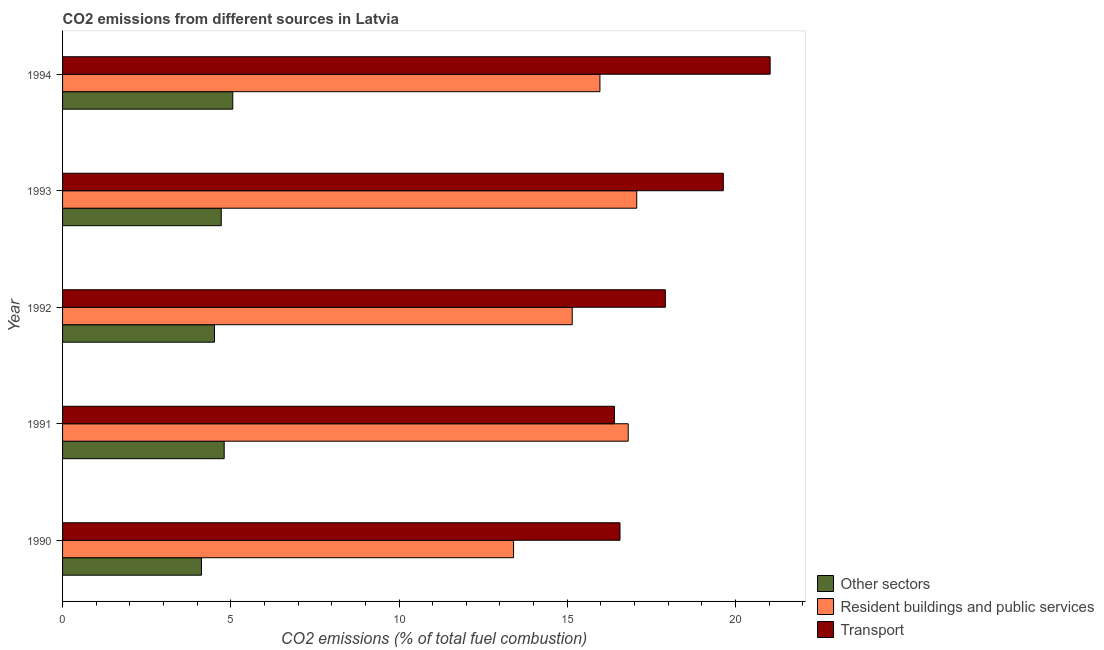How many groups of bars are there?
Offer a very short reply. 5. Are the number of bars on each tick of the Y-axis equal?
Your answer should be very brief. Yes. What is the label of the 2nd group of bars from the top?
Give a very brief answer. 1993. In how many cases, is the number of bars for a given year not equal to the number of legend labels?
Make the answer very short. 0. What is the percentage of co2 emissions from transport in 1993?
Make the answer very short. 19.64. Across all years, what is the maximum percentage of co2 emissions from other sectors?
Your answer should be very brief. 5.06. Across all years, what is the minimum percentage of co2 emissions from transport?
Provide a short and direct response. 16.4. In which year was the percentage of co2 emissions from other sectors maximum?
Ensure brevity in your answer.  1994. In which year was the percentage of co2 emissions from transport minimum?
Provide a short and direct response. 1991. What is the total percentage of co2 emissions from other sectors in the graph?
Your response must be concise. 23.22. What is the difference between the percentage of co2 emissions from other sectors in 1990 and that in 1994?
Give a very brief answer. -0.93. What is the difference between the percentage of co2 emissions from transport in 1992 and the percentage of co2 emissions from other sectors in 1993?
Provide a succinct answer. 13.2. What is the average percentage of co2 emissions from other sectors per year?
Provide a succinct answer. 4.64. In the year 1994, what is the difference between the percentage of co2 emissions from transport and percentage of co2 emissions from other sectors?
Provide a short and direct response. 15.97. What is the ratio of the percentage of co2 emissions from other sectors in 1990 to that in 1992?
Your answer should be compact. 0.91. What is the difference between the highest and the second highest percentage of co2 emissions from resident buildings and public services?
Your answer should be compact. 0.25. What is the difference between the highest and the lowest percentage of co2 emissions from resident buildings and public services?
Provide a short and direct response. 3.66. In how many years, is the percentage of co2 emissions from transport greater than the average percentage of co2 emissions from transport taken over all years?
Offer a terse response. 2. What does the 3rd bar from the top in 1992 represents?
Ensure brevity in your answer.  Other sectors. What does the 3rd bar from the bottom in 1991 represents?
Ensure brevity in your answer.  Transport. Does the graph contain any zero values?
Your answer should be compact. No. Where does the legend appear in the graph?
Give a very brief answer. Bottom right. How are the legend labels stacked?
Provide a succinct answer. Vertical. What is the title of the graph?
Your answer should be very brief. CO2 emissions from different sources in Latvia. Does "Industry" appear as one of the legend labels in the graph?
Offer a very short reply. No. What is the label or title of the X-axis?
Ensure brevity in your answer.  CO2 emissions (% of total fuel combustion). What is the label or title of the Y-axis?
Your answer should be very brief. Year. What is the CO2 emissions (% of total fuel combustion) in Other sectors in 1990?
Provide a succinct answer. 4.13. What is the CO2 emissions (% of total fuel combustion) in Resident buildings and public services in 1990?
Provide a succinct answer. 13.4. What is the CO2 emissions (% of total fuel combustion) of Transport in 1990?
Provide a succinct answer. 16.57. What is the CO2 emissions (% of total fuel combustion) in Other sectors in 1991?
Your answer should be compact. 4.8. What is the CO2 emissions (% of total fuel combustion) of Resident buildings and public services in 1991?
Your response must be concise. 16.81. What is the CO2 emissions (% of total fuel combustion) in Transport in 1991?
Keep it short and to the point. 16.4. What is the CO2 emissions (% of total fuel combustion) in Other sectors in 1992?
Your answer should be compact. 4.52. What is the CO2 emissions (% of total fuel combustion) of Resident buildings and public services in 1992?
Keep it short and to the point. 15.15. What is the CO2 emissions (% of total fuel combustion) of Transport in 1992?
Offer a terse response. 17.92. What is the CO2 emissions (% of total fuel combustion) in Other sectors in 1993?
Provide a succinct answer. 4.72. What is the CO2 emissions (% of total fuel combustion) of Resident buildings and public services in 1993?
Provide a short and direct response. 17.07. What is the CO2 emissions (% of total fuel combustion) in Transport in 1993?
Your answer should be very brief. 19.64. What is the CO2 emissions (% of total fuel combustion) of Other sectors in 1994?
Give a very brief answer. 5.06. What is the CO2 emissions (% of total fuel combustion) in Resident buildings and public services in 1994?
Make the answer very short. 15.97. What is the CO2 emissions (% of total fuel combustion) in Transport in 1994?
Ensure brevity in your answer.  21.03. Across all years, what is the maximum CO2 emissions (% of total fuel combustion) in Other sectors?
Your answer should be very brief. 5.06. Across all years, what is the maximum CO2 emissions (% of total fuel combustion) in Resident buildings and public services?
Your answer should be very brief. 17.07. Across all years, what is the maximum CO2 emissions (% of total fuel combustion) of Transport?
Offer a terse response. 21.03. Across all years, what is the minimum CO2 emissions (% of total fuel combustion) in Other sectors?
Provide a short and direct response. 4.13. Across all years, what is the minimum CO2 emissions (% of total fuel combustion) of Resident buildings and public services?
Keep it short and to the point. 13.4. Across all years, what is the minimum CO2 emissions (% of total fuel combustion) of Transport?
Make the answer very short. 16.4. What is the total CO2 emissions (% of total fuel combustion) in Other sectors in the graph?
Give a very brief answer. 23.22. What is the total CO2 emissions (% of total fuel combustion) in Resident buildings and public services in the graph?
Give a very brief answer. 78.41. What is the total CO2 emissions (% of total fuel combustion) in Transport in the graph?
Give a very brief answer. 91.56. What is the difference between the CO2 emissions (% of total fuel combustion) in Other sectors in 1990 and that in 1991?
Offer a terse response. -0.68. What is the difference between the CO2 emissions (% of total fuel combustion) of Resident buildings and public services in 1990 and that in 1991?
Provide a short and direct response. -3.41. What is the difference between the CO2 emissions (% of total fuel combustion) in Transport in 1990 and that in 1991?
Your answer should be compact. 0.17. What is the difference between the CO2 emissions (% of total fuel combustion) of Other sectors in 1990 and that in 1992?
Ensure brevity in your answer.  -0.39. What is the difference between the CO2 emissions (% of total fuel combustion) of Resident buildings and public services in 1990 and that in 1992?
Your answer should be compact. -1.74. What is the difference between the CO2 emissions (% of total fuel combustion) in Transport in 1990 and that in 1992?
Keep it short and to the point. -1.35. What is the difference between the CO2 emissions (% of total fuel combustion) of Other sectors in 1990 and that in 1993?
Your answer should be compact. -0.59. What is the difference between the CO2 emissions (% of total fuel combustion) in Resident buildings and public services in 1990 and that in 1993?
Provide a short and direct response. -3.66. What is the difference between the CO2 emissions (% of total fuel combustion) of Transport in 1990 and that in 1993?
Offer a very short reply. -3.07. What is the difference between the CO2 emissions (% of total fuel combustion) in Other sectors in 1990 and that in 1994?
Keep it short and to the point. -0.93. What is the difference between the CO2 emissions (% of total fuel combustion) of Resident buildings and public services in 1990 and that in 1994?
Your response must be concise. -2.57. What is the difference between the CO2 emissions (% of total fuel combustion) in Transport in 1990 and that in 1994?
Keep it short and to the point. -4.46. What is the difference between the CO2 emissions (% of total fuel combustion) of Other sectors in 1991 and that in 1992?
Your answer should be very brief. 0.29. What is the difference between the CO2 emissions (% of total fuel combustion) in Resident buildings and public services in 1991 and that in 1992?
Your response must be concise. 1.66. What is the difference between the CO2 emissions (% of total fuel combustion) of Transport in 1991 and that in 1992?
Offer a terse response. -1.51. What is the difference between the CO2 emissions (% of total fuel combustion) of Other sectors in 1991 and that in 1993?
Offer a terse response. 0.09. What is the difference between the CO2 emissions (% of total fuel combustion) of Resident buildings and public services in 1991 and that in 1993?
Ensure brevity in your answer.  -0.25. What is the difference between the CO2 emissions (% of total fuel combustion) of Transport in 1991 and that in 1993?
Your answer should be very brief. -3.24. What is the difference between the CO2 emissions (% of total fuel combustion) in Other sectors in 1991 and that in 1994?
Ensure brevity in your answer.  -0.26. What is the difference between the CO2 emissions (% of total fuel combustion) in Resident buildings and public services in 1991 and that in 1994?
Make the answer very short. 0.84. What is the difference between the CO2 emissions (% of total fuel combustion) in Transport in 1991 and that in 1994?
Offer a very short reply. -4.63. What is the difference between the CO2 emissions (% of total fuel combustion) of Other sectors in 1992 and that in 1993?
Ensure brevity in your answer.  -0.2. What is the difference between the CO2 emissions (% of total fuel combustion) of Resident buildings and public services in 1992 and that in 1993?
Your response must be concise. -1.92. What is the difference between the CO2 emissions (% of total fuel combustion) in Transport in 1992 and that in 1993?
Provide a short and direct response. -1.72. What is the difference between the CO2 emissions (% of total fuel combustion) of Other sectors in 1992 and that in 1994?
Your answer should be compact. -0.54. What is the difference between the CO2 emissions (% of total fuel combustion) of Resident buildings and public services in 1992 and that in 1994?
Keep it short and to the point. -0.82. What is the difference between the CO2 emissions (% of total fuel combustion) of Transport in 1992 and that in 1994?
Your answer should be very brief. -3.11. What is the difference between the CO2 emissions (% of total fuel combustion) of Other sectors in 1993 and that in 1994?
Give a very brief answer. -0.34. What is the difference between the CO2 emissions (% of total fuel combustion) of Resident buildings and public services in 1993 and that in 1994?
Offer a very short reply. 1.09. What is the difference between the CO2 emissions (% of total fuel combustion) of Transport in 1993 and that in 1994?
Offer a terse response. -1.39. What is the difference between the CO2 emissions (% of total fuel combustion) of Other sectors in 1990 and the CO2 emissions (% of total fuel combustion) of Resident buildings and public services in 1991?
Provide a succinct answer. -12.68. What is the difference between the CO2 emissions (% of total fuel combustion) in Other sectors in 1990 and the CO2 emissions (% of total fuel combustion) in Transport in 1991?
Ensure brevity in your answer.  -12.27. What is the difference between the CO2 emissions (% of total fuel combustion) in Resident buildings and public services in 1990 and the CO2 emissions (% of total fuel combustion) in Transport in 1991?
Your answer should be very brief. -3. What is the difference between the CO2 emissions (% of total fuel combustion) in Other sectors in 1990 and the CO2 emissions (% of total fuel combustion) in Resident buildings and public services in 1992?
Your answer should be compact. -11.02. What is the difference between the CO2 emissions (% of total fuel combustion) of Other sectors in 1990 and the CO2 emissions (% of total fuel combustion) of Transport in 1992?
Offer a very short reply. -13.79. What is the difference between the CO2 emissions (% of total fuel combustion) of Resident buildings and public services in 1990 and the CO2 emissions (% of total fuel combustion) of Transport in 1992?
Your answer should be very brief. -4.51. What is the difference between the CO2 emissions (% of total fuel combustion) in Other sectors in 1990 and the CO2 emissions (% of total fuel combustion) in Resident buildings and public services in 1993?
Your answer should be very brief. -12.94. What is the difference between the CO2 emissions (% of total fuel combustion) of Other sectors in 1990 and the CO2 emissions (% of total fuel combustion) of Transport in 1993?
Offer a terse response. -15.51. What is the difference between the CO2 emissions (% of total fuel combustion) in Resident buildings and public services in 1990 and the CO2 emissions (% of total fuel combustion) in Transport in 1993?
Your answer should be compact. -6.24. What is the difference between the CO2 emissions (% of total fuel combustion) of Other sectors in 1990 and the CO2 emissions (% of total fuel combustion) of Resident buildings and public services in 1994?
Make the answer very short. -11.84. What is the difference between the CO2 emissions (% of total fuel combustion) in Other sectors in 1990 and the CO2 emissions (% of total fuel combustion) in Transport in 1994?
Give a very brief answer. -16.9. What is the difference between the CO2 emissions (% of total fuel combustion) of Resident buildings and public services in 1990 and the CO2 emissions (% of total fuel combustion) of Transport in 1994?
Provide a short and direct response. -7.63. What is the difference between the CO2 emissions (% of total fuel combustion) in Other sectors in 1991 and the CO2 emissions (% of total fuel combustion) in Resident buildings and public services in 1992?
Provide a short and direct response. -10.35. What is the difference between the CO2 emissions (% of total fuel combustion) in Other sectors in 1991 and the CO2 emissions (% of total fuel combustion) in Transport in 1992?
Give a very brief answer. -13.11. What is the difference between the CO2 emissions (% of total fuel combustion) in Resident buildings and public services in 1991 and the CO2 emissions (% of total fuel combustion) in Transport in 1992?
Your response must be concise. -1.1. What is the difference between the CO2 emissions (% of total fuel combustion) in Other sectors in 1991 and the CO2 emissions (% of total fuel combustion) in Resident buildings and public services in 1993?
Offer a terse response. -12.26. What is the difference between the CO2 emissions (% of total fuel combustion) in Other sectors in 1991 and the CO2 emissions (% of total fuel combustion) in Transport in 1993?
Your answer should be compact. -14.84. What is the difference between the CO2 emissions (% of total fuel combustion) of Resident buildings and public services in 1991 and the CO2 emissions (% of total fuel combustion) of Transport in 1993?
Ensure brevity in your answer.  -2.83. What is the difference between the CO2 emissions (% of total fuel combustion) of Other sectors in 1991 and the CO2 emissions (% of total fuel combustion) of Resident buildings and public services in 1994?
Your response must be concise. -11.17. What is the difference between the CO2 emissions (% of total fuel combustion) of Other sectors in 1991 and the CO2 emissions (% of total fuel combustion) of Transport in 1994?
Your answer should be very brief. -16.23. What is the difference between the CO2 emissions (% of total fuel combustion) in Resident buildings and public services in 1991 and the CO2 emissions (% of total fuel combustion) in Transport in 1994?
Offer a very short reply. -4.22. What is the difference between the CO2 emissions (% of total fuel combustion) of Other sectors in 1992 and the CO2 emissions (% of total fuel combustion) of Resident buildings and public services in 1993?
Offer a terse response. -12.55. What is the difference between the CO2 emissions (% of total fuel combustion) of Other sectors in 1992 and the CO2 emissions (% of total fuel combustion) of Transport in 1993?
Give a very brief answer. -15.12. What is the difference between the CO2 emissions (% of total fuel combustion) in Resident buildings and public services in 1992 and the CO2 emissions (% of total fuel combustion) in Transport in 1993?
Keep it short and to the point. -4.49. What is the difference between the CO2 emissions (% of total fuel combustion) in Other sectors in 1992 and the CO2 emissions (% of total fuel combustion) in Resident buildings and public services in 1994?
Keep it short and to the point. -11.46. What is the difference between the CO2 emissions (% of total fuel combustion) of Other sectors in 1992 and the CO2 emissions (% of total fuel combustion) of Transport in 1994?
Provide a short and direct response. -16.52. What is the difference between the CO2 emissions (% of total fuel combustion) of Resident buildings and public services in 1992 and the CO2 emissions (% of total fuel combustion) of Transport in 1994?
Keep it short and to the point. -5.88. What is the difference between the CO2 emissions (% of total fuel combustion) of Other sectors in 1993 and the CO2 emissions (% of total fuel combustion) of Resident buildings and public services in 1994?
Ensure brevity in your answer.  -11.26. What is the difference between the CO2 emissions (% of total fuel combustion) of Other sectors in 1993 and the CO2 emissions (% of total fuel combustion) of Transport in 1994?
Your answer should be very brief. -16.31. What is the difference between the CO2 emissions (% of total fuel combustion) in Resident buildings and public services in 1993 and the CO2 emissions (% of total fuel combustion) in Transport in 1994?
Your answer should be compact. -3.96. What is the average CO2 emissions (% of total fuel combustion) of Other sectors per year?
Your answer should be compact. 4.64. What is the average CO2 emissions (% of total fuel combustion) of Resident buildings and public services per year?
Keep it short and to the point. 15.68. What is the average CO2 emissions (% of total fuel combustion) of Transport per year?
Your answer should be very brief. 18.31. In the year 1990, what is the difference between the CO2 emissions (% of total fuel combustion) in Other sectors and CO2 emissions (% of total fuel combustion) in Resident buildings and public services?
Ensure brevity in your answer.  -9.28. In the year 1990, what is the difference between the CO2 emissions (% of total fuel combustion) in Other sectors and CO2 emissions (% of total fuel combustion) in Transport?
Make the answer very short. -12.44. In the year 1990, what is the difference between the CO2 emissions (% of total fuel combustion) in Resident buildings and public services and CO2 emissions (% of total fuel combustion) in Transport?
Keep it short and to the point. -3.16. In the year 1991, what is the difference between the CO2 emissions (% of total fuel combustion) in Other sectors and CO2 emissions (% of total fuel combustion) in Resident buildings and public services?
Ensure brevity in your answer.  -12.01. In the year 1991, what is the difference between the CO2 emissions (% of total fuel combustion) in Other sectors and CO2 emissions (% of total fuel combustion) in Transport?
Offer a terse response. -11.6. In the year 1991, what is the difference between the CO2 emissions (% of total fuel combustion) of Resident buildings and public services and CO2 emissions (% of total fuel combustion) of Transport?
Keep it short and to the point. 0.41. In the year 1992, what is the difference between the CO2 emissions (% of total fuel combustion) of Other sectors and CO2 emissions (% of total fuel combustion) of Resident buildings and public services?
Offer a terse response. -10.63. In the year 1992, what is the difference between the CO2 emissions (% of total fuel combustion) of Other sectors and CO2 emissions (% of total fuel combustion) of Transport?
Keep it short and to the point. -13.4. In the year 1992, what is the difference between the CO2 emissions (% of total fuel combustion) in Resident buildings and public services and CO2 emissions (% of total fuel combustion) in Transport?
Your answer should be very brief. -2.77. In the year 1993, what is the difference between the CO2 emissions (% of total fuel combustion) in Other sectors and CO2 emissions (% of total fuel combustion) in Resident buildings and public services?
Ensure brevity in your answer.  -12.35. In the year 1993, what is the difference between the CO2 emissions (% of total fuel combustion) of Other sectors and CO2 emissions (% of total fuel combustion) of Transport?
Provide a short and direct response. -14.92. In the year 1993, what is the difference between the CO2 emissions (% of total fuel combustion) of Resident buildings and public services and CO2 emissions (% of total fuel combustion) of Transport?
Your answer should be very brief. -2.57. In the year 1994, what is the difference between the CO2 emissions (% of total fuel combustion) of Other sectors and CO2 emissions (% of total fuel combustion) of Resident buildings and public services?
Your answer should be very brief. -10.91. In the year 1994, what is the difference between the CO2 emissions (% of total fuel combustion) in Other sectors and CO2 emissions (% of total fuel combustion) in Transport?
Provide a short and direct response. -15.97. In the year 1994, what is the difference between the CO2 emissions (% of total fuel combustion) of Resident buildings and public services and CO2 emissions (% of total fuel combustion) of Transport?
Provide a short and direct response. -5.06. What is the ratio of the CO2 emissions (% of total fuel combustion) of Other sectors in 1990 to that in 1991?
Offer a terse response. 0.86. What is the ratio of the CO2 emissions (% of total fuel combustion) in Resident buildings and public services in 1990 to that in 1991?
Offer a terse response. 0.8. What is the ratio of the CO2 emissions (% of total fuel combustion) of Transport in 1990 to that in 1991?
Ensure brevity in your answer.  1.01. What is the ratio of the CO2 emissions (% of total fuel combustion) in Other sectors in 1990 to that in 1992?
Your answer should be very brief. 0.91. What is the ratio of the CO2 emissions (% of total fuel combustion) in Resident buildings and public services in 1990 to that in 1992?
Keep it short and to the point. 0.88. What is the ratio of the CO2 emissions (% of total fuel combustion) in Transport in 1990 to that in 1992?
Provide a short and direct response. 0.92. What is the ratio of the CO2 emissions (% of total fuel combustion) in Other sectors in 1990 to that in 1993?
Your answer should be very brief. 0.88. What is the ratio of the CO2 emissions (% of total fuel combustion) in Resident buildings and public services in 1990 to that in 1993?
Provide a succinct answer. 0.79. What is the ratio of the CO2 emissions (% of total fuel combustion) in Transport in 1990 to that in 1993?
Provide a succinct answer. 0.84. What is the ratio of the CO2 emissions (% of total fuel combustion) of Other sectors in 1990 to that in 1994?
Provide a succinct answer. 0.82. What is the ratio of the CO2 emissions (% of total fuel combustion) in Resident buildings and public services in 1990 to that in 1994?
Provide a short and direct response. 0.84. What is the ratio of the CO2 emissions (% of total fuel combustion) in Transport in 1990 to that in 1994?
Make the answer very short. 0.79. What is the ratio of the CO2 emissions (% of total fuel combustion) in Other sectors in 1991 to that in 1992?
Your answer should be very brief. 1.06. What is the ratio of the CO2 emissions (% of total fuel combustion) in Resident buildings and public services in 1991 to that in 1992?
Provide a succinct answer. 1.11. What is the ratio of the CO2 emissions (% of total fuel combustion) in Transport in 1991 to that in 1992?
Your response must be concise. 0.92. What is the ratio of the CO2 emissions (% of total fuel combustion) in Other sectors in 1991 to that in 1993?
Your answer should be compact. 1.02. What is the ratio of the CO2 emissions (% of total fuel combustion) in Resident buildings and public services in 1991 to that in 1993?
Offer a very short reply. 0.99. What is the ratio of the CO2 emissions (% of total fuel combustion) of Transport in 1991 to that in 1993?
Offer a terse response. 0.84. What is the ratio of the CO2 emissions (% of total fuel combustion) of Other sectors in 1991 to that in 1994?
Your answer should be compact. 0.95. What is the ratio of the CO2 emissions (% of total fuel combustion) in Resident buildings and public services in 1991 to that in 1994?
Ensure brevity in your answer.  1.05. What is the ratio of the CO2 emissions (% of total fuel combustion) of Transport in 1991 to that in 1994?
Give a very brief answer. 0.78. What is the ratio of the CO2 emissions (% of total fuel combustion) of Other sectors in 1992 to that in 1993?
Your response must be concise. 0.96. What is the ratio of the CO2 emissions (% of total fuel combustion) of Resident buildings and public services in 1992 to that in 1993?
Offer a terse response. 0.89. What is the ratio of the CO2 emissions (% of total fuel combustion) of Transport in 1992 to that in 1993?
Keep it short and to the point. 0.91. What is the ratio of the CO2 emissions (% of total fuel combustion) in Other sectors in 1992 to that in 1994?
Your response must be concise. 0.89. What is the ratio of the CO2 emissions (% of total fuel combustion) of Resident buildings and public services in 1992 to that in 1994?
Your response must be concise. 0.95. What is the ratio of the CO2 emissions (% of total fuel combustion) in Transport in 1992 to that in 1994?
Make the answer very short. 0.85. What is the ratio of the CO2 emissions (% of total fuel combustion) of Other sectors in 1993 to that in 1994?
Your answer should be compact. 0.93. What is the ratio of the CO2 emissions (% of total fuel combustion) in Resident buildings and public services in 1993 to that in 1994?
Your response must be concise. 1.07. What is the ratio of the CO2 emissions (% of total fuel combustion) of Transport in 1993 to that in 1994?
Give a very brief answer. 0.93. What is the difference between the highest and the second highest CO2 emissions (% of total fuel combustion) of Other sectors?
Keep it short and to the point. 0.26. What is the difference between the highest and the second highest CO2 emissions (% of total fuel combustion) of Resident buildings and public services?
Ensure brevity in your answer.  0.25. What is the difference between the highest and the second highest CO2 emissions (% of total fuel combustion) in Transport?
Keep it short and to the point. 1.39. What is the difference between the highest and the lowest CO2 emissions (% of total fuel combustion) of Other sectors?
Offer a very short reply. 0.93. What is the difference between the highest and the lowest CO2 emissions (% of total fuel combustion) of Resident buildings and public services?
Offer a terse response. 3.66. What is the difference between the highest and the lowest CO2 emissions (% of total fuel combustion) of Transport?
Your answer should be very brief. 4.63. 